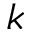Convert formula to latex. <formula><loc_0><loc_0><loc_500><loc_500>k</formula> 